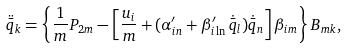<formula> <loc_0><loc_0><loc_500><loc_500>\ddot { \bar { q } } _ { k } = \left \{ \frac { 1 } { m } P _ { 2 m } - \left [ \frac { u _ { i } } { m } + ( \alpha ^ { \prime } _ { i n } + \beta ^ { \prime } _ { i \ln } \, \dot { \bar { q } } _ { l } ) \dot { \bar { q } } _ { n } \right ] \beta _ { i m } \right \} B _ { m k } ,</formula> 